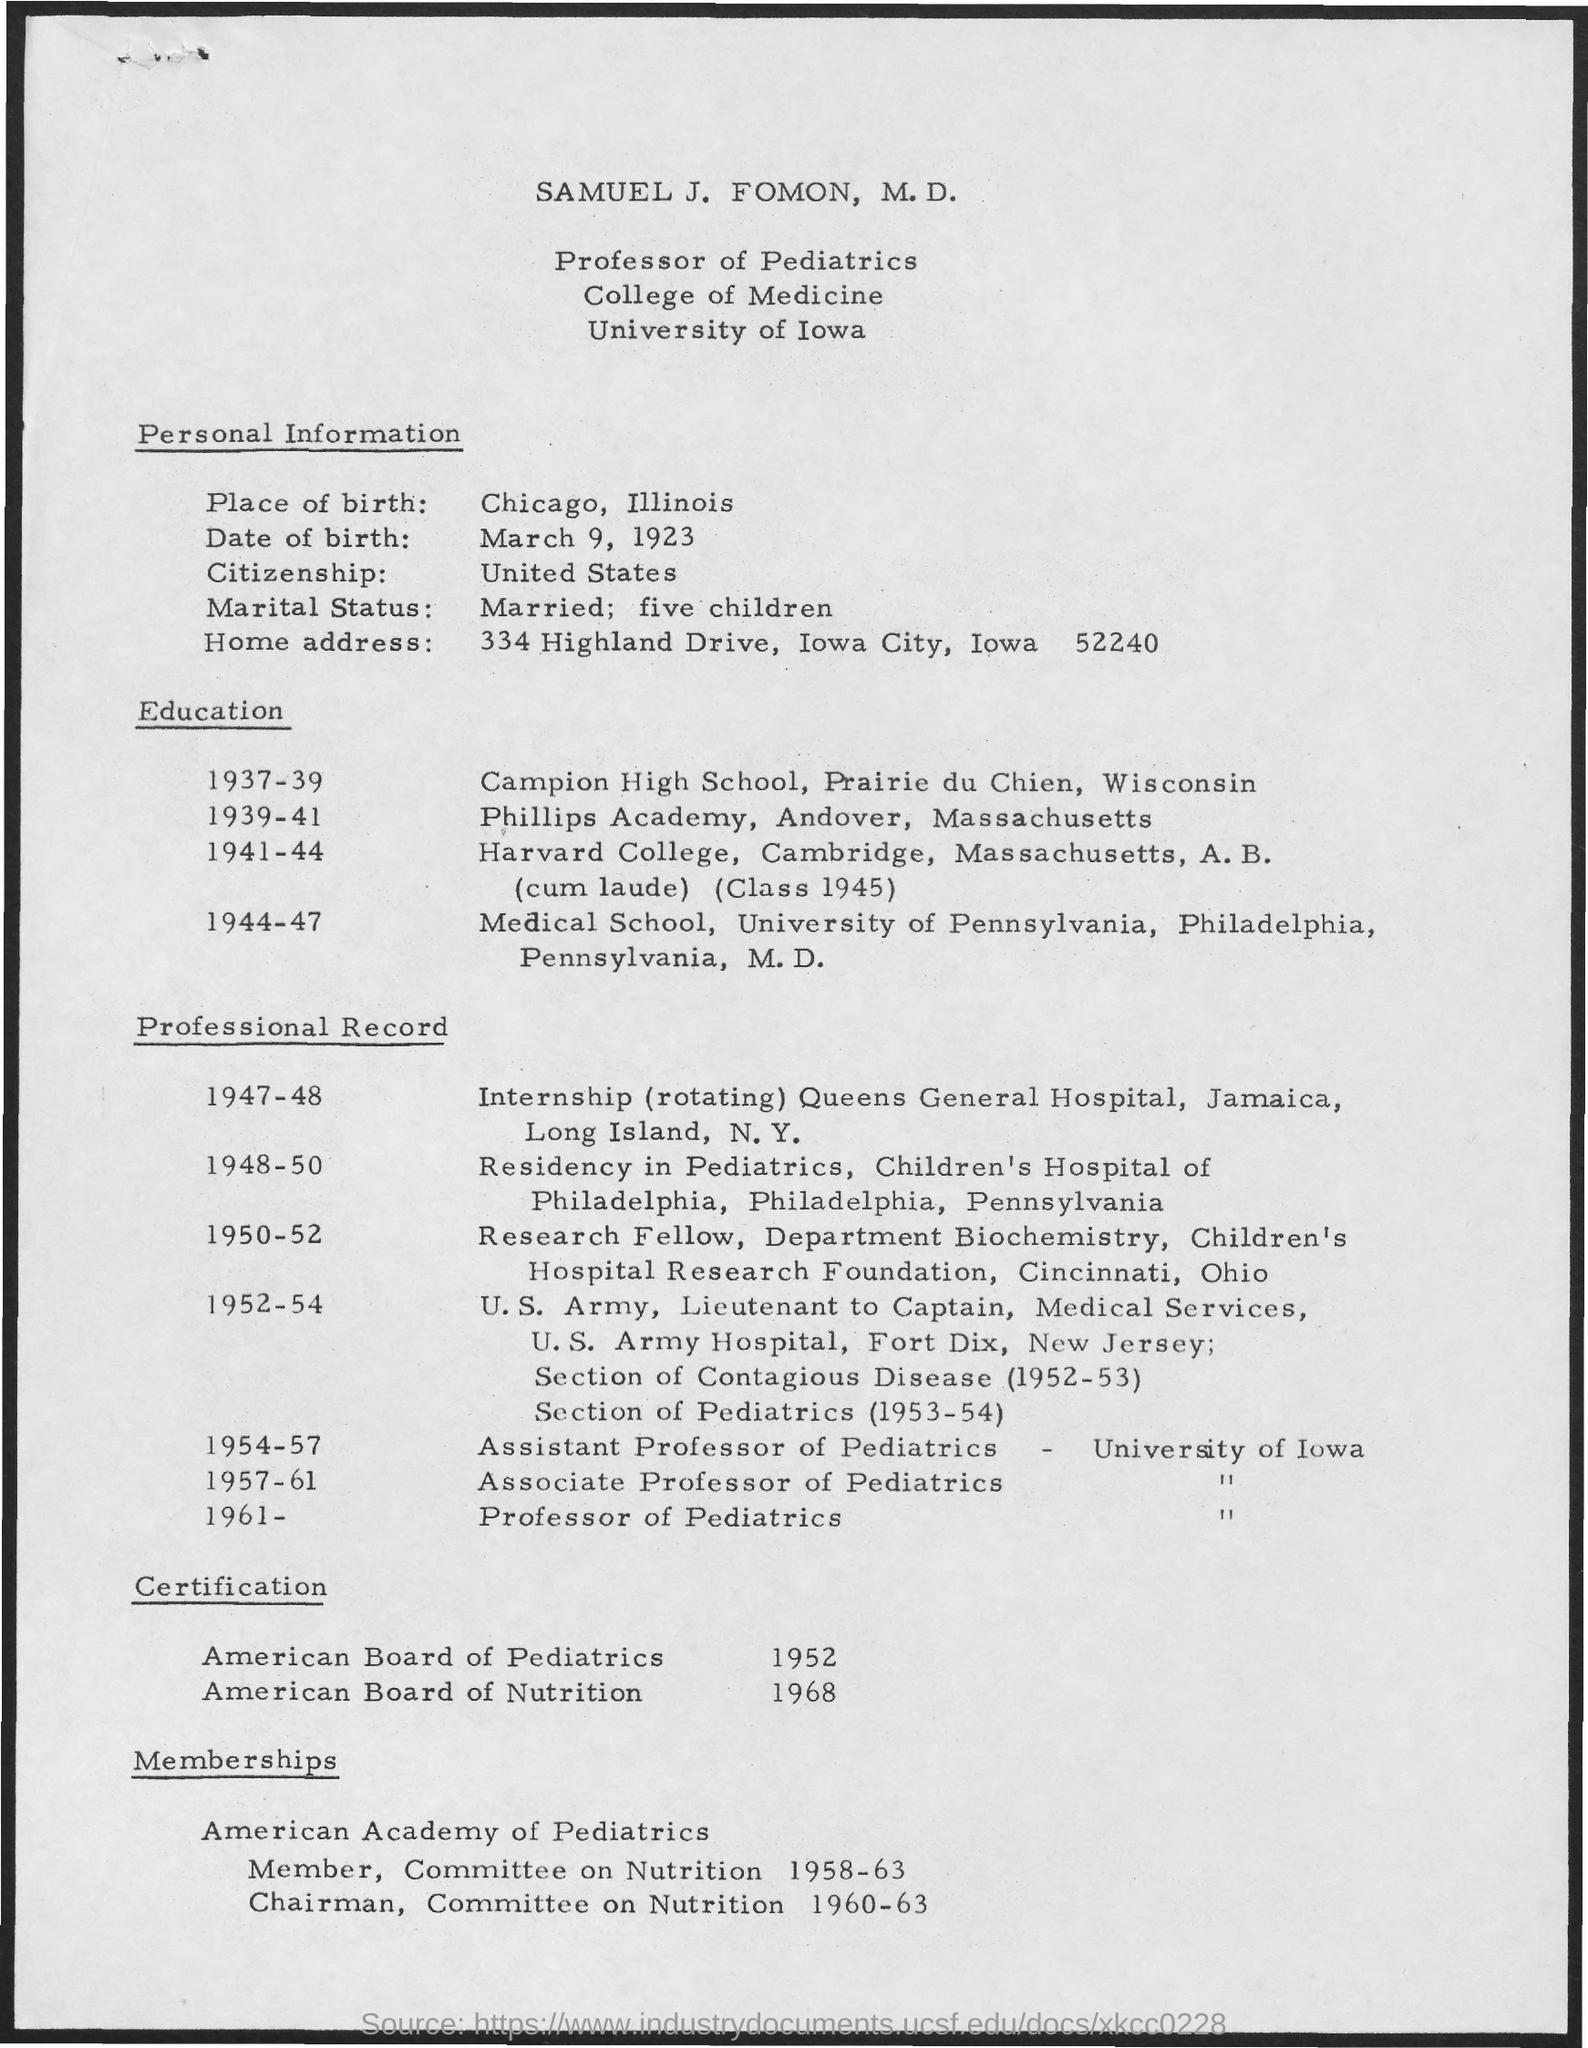Indicate a few pertinent items in this graphic. In the year 1952, he obtained certification from the American Board of Pediatrics. In the year 1968, Dr. Fuhrman obtained his certification from the American Board of Nutrition. The individual was a member of the Committee on Nutrition during the years 1958 to 1963. Chicago, Illinois is the place of birth. John has the citizenship of the United States in which he resides. 